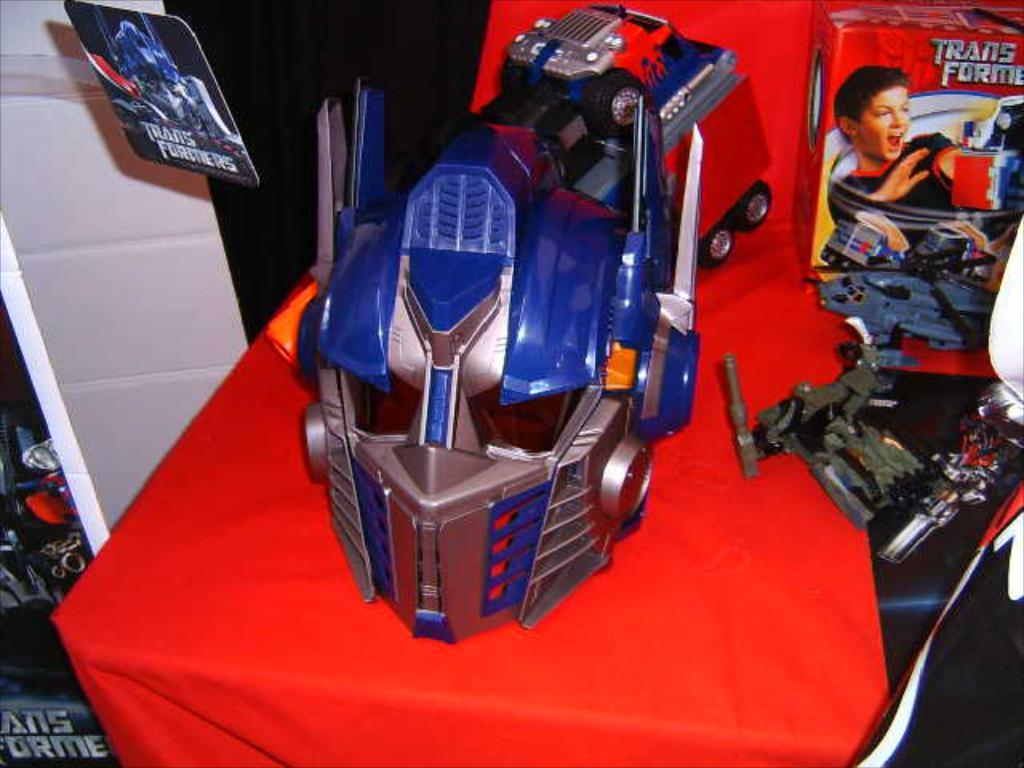<image>
Offer a succinct explanation of the picture presented. The word transformer is seen next to an image of a transformer. 